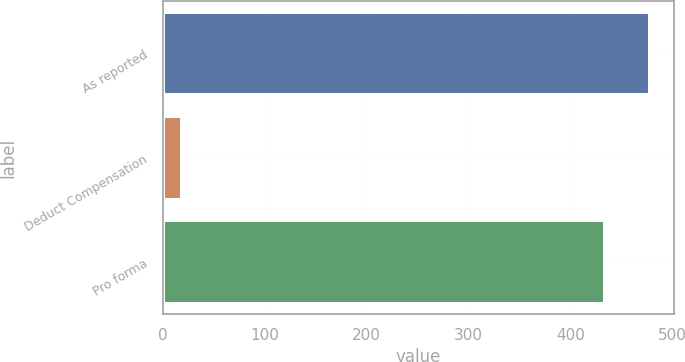Convert chart. <chart><loc_0><loc_0><loc_500><loc_500><bar_chart><fcel>As reported<fcel>Deduct Compensation<fcel>Pro forma<nl><fcel>477.84<fcel>19.1<fcel>434.4<nl></chart> 